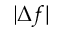<formula> <loc_0><loc_0><loc_500><loc_500>| \Delta f |</formula> 